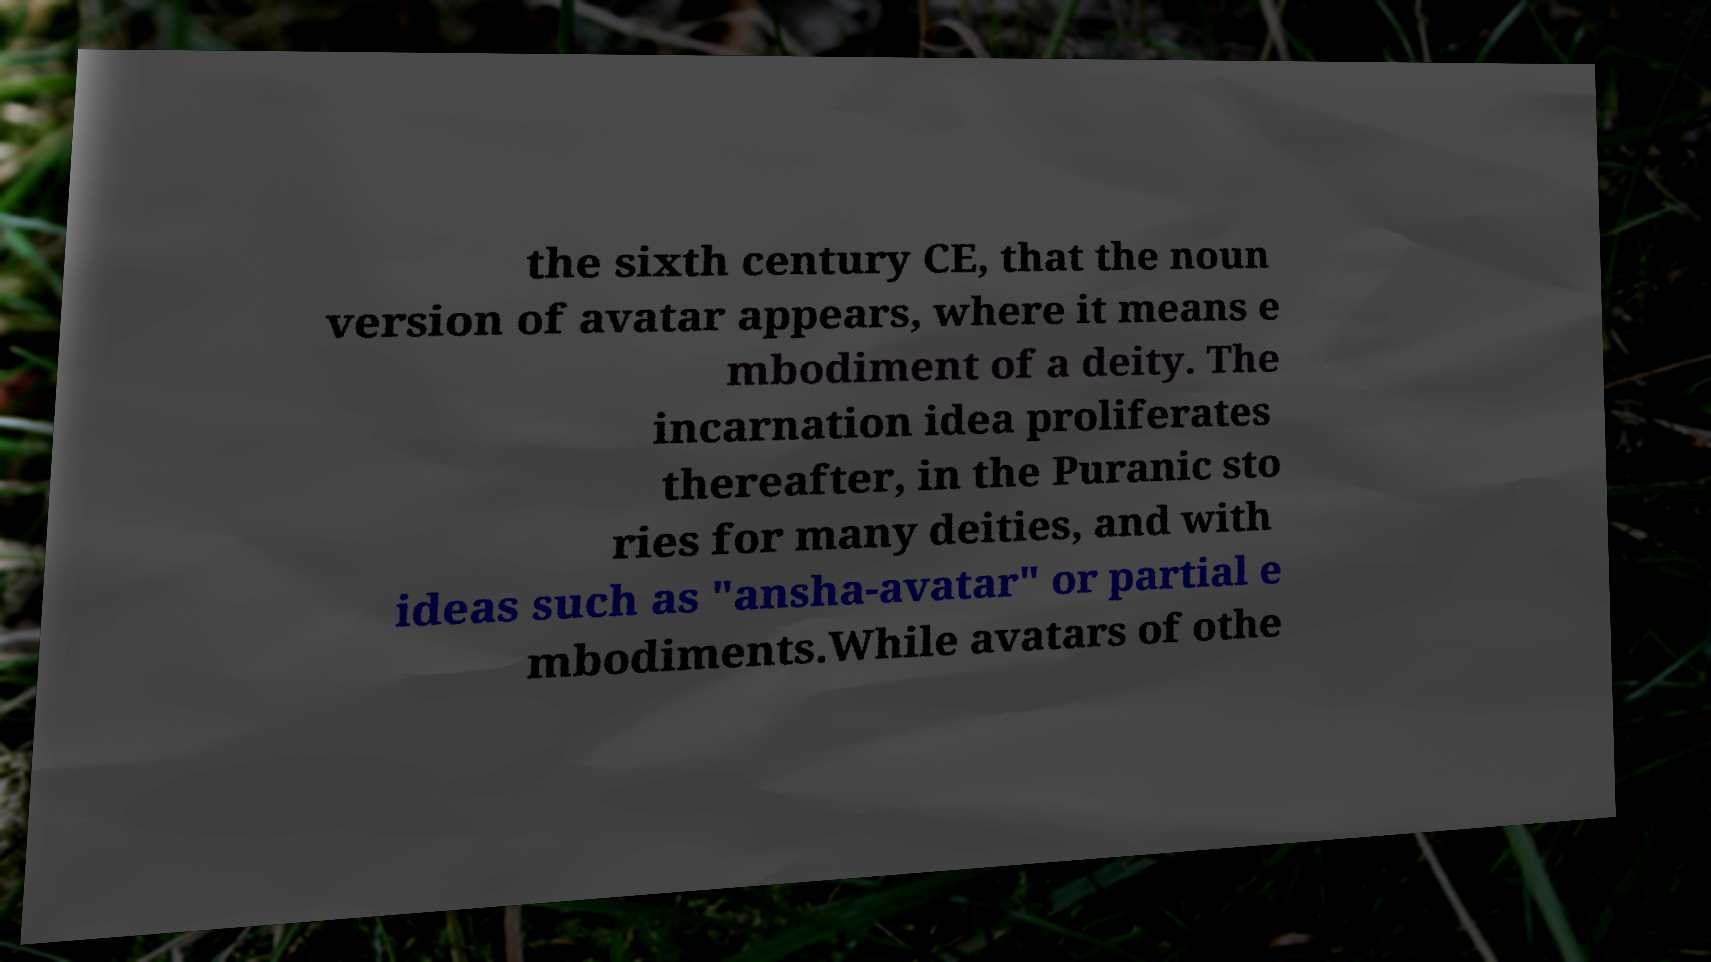Can you read and provide the text displayed in the image?This photo seems to have some interesting text. Can you extract and type it out for me? the sixth century CE, that the noun version of avatar appears, where it means e mbodiment of a deity. The incarnation idea proliferates thereafter, in the Puranic sto ries for many deities, and with ideas such as "ansha-avatar" or partial e mbodiments.While avatars of othe 